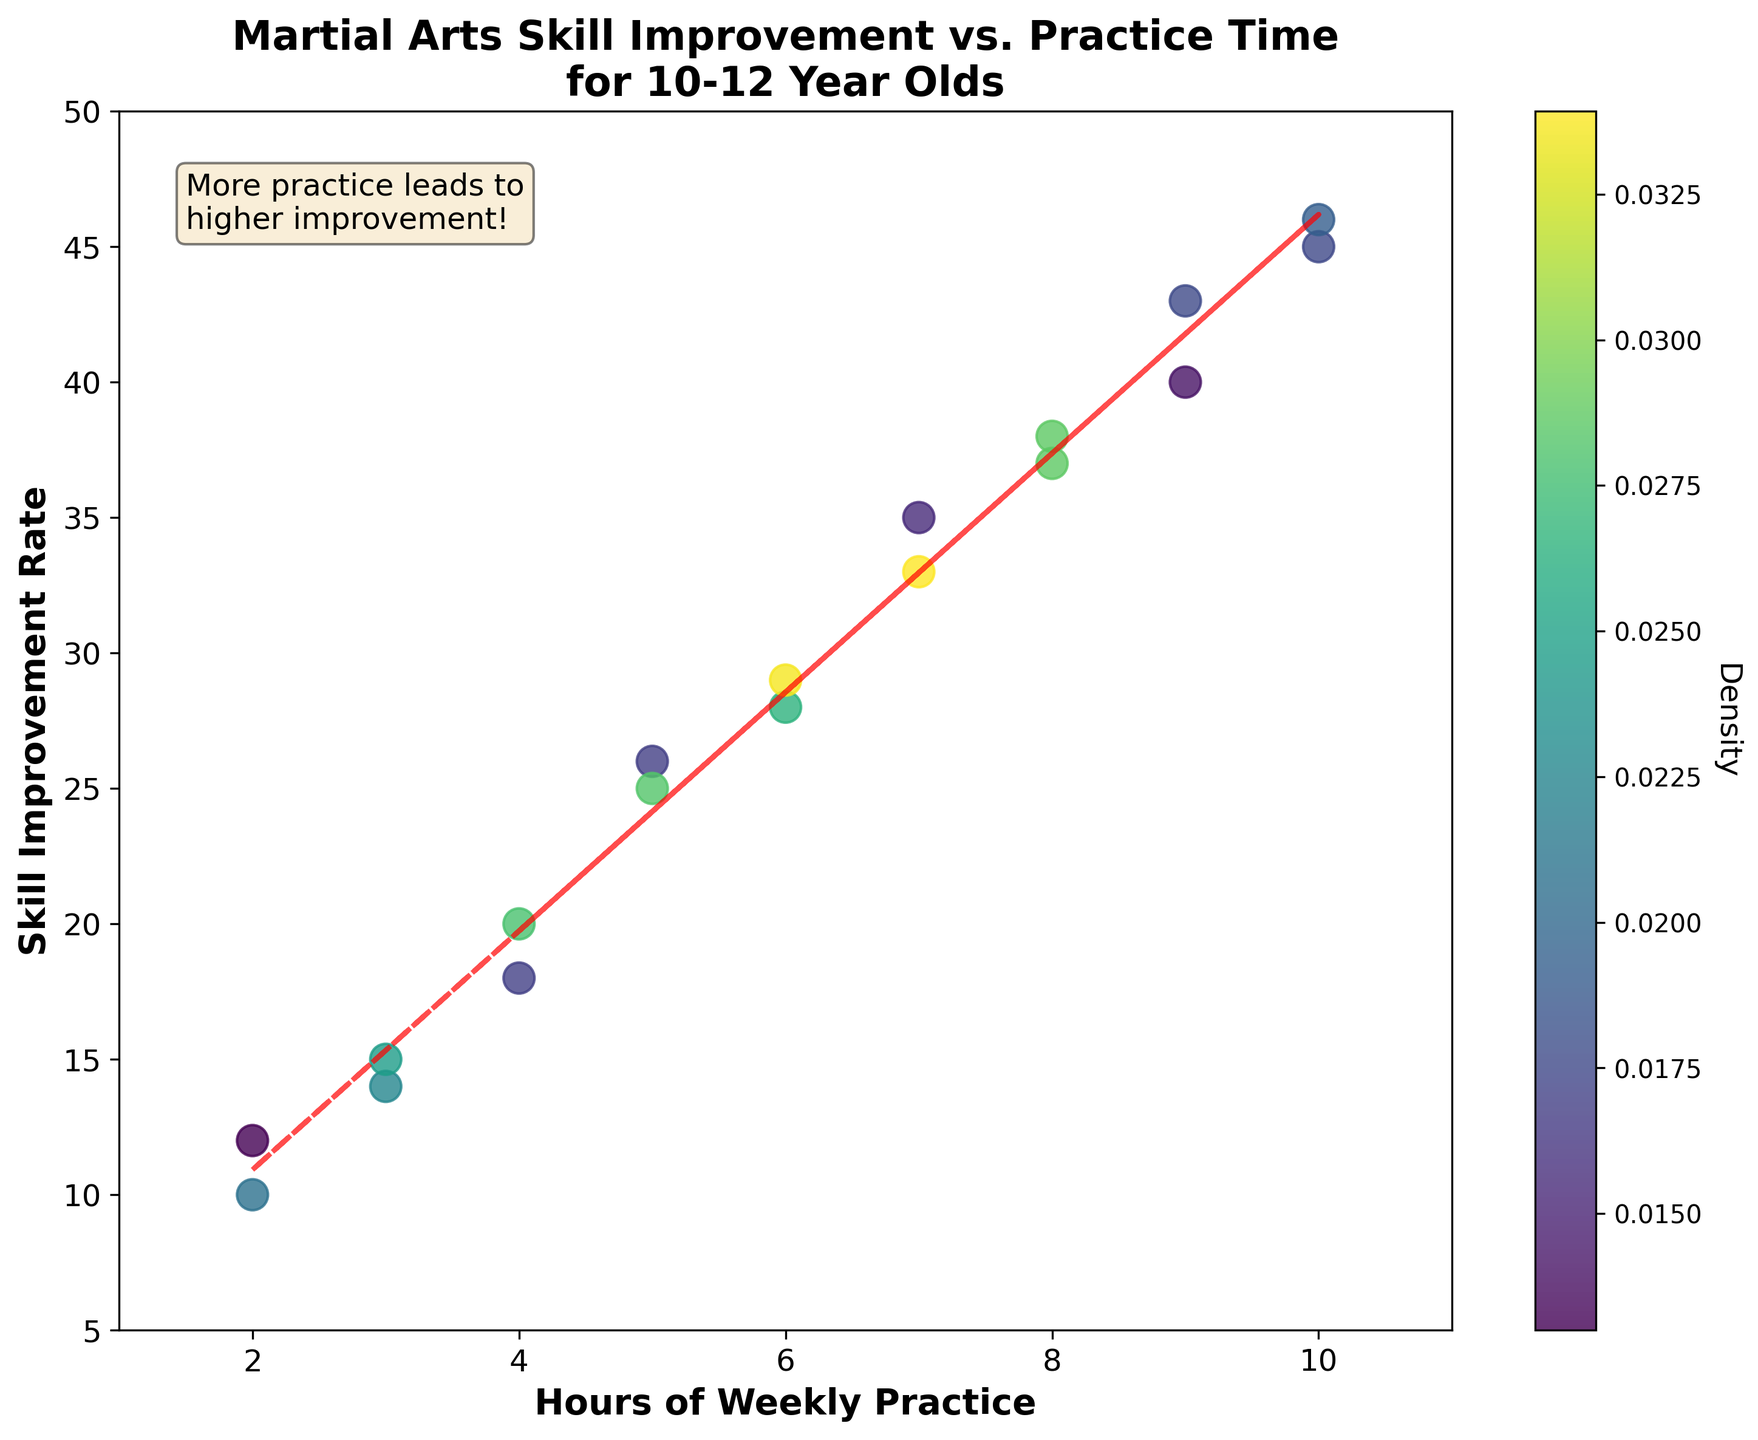What is the title of the plot? The title is located at the top center of the plot and describes what the plot is about.
Answer: Martial Arts Skill Improvement vs. Practice Time for 10-12 Year Olds What are the labels for the x-axis and y-axis? The x-axis label is at the bottom along the horizontal axis, and the y-axis label is on the left along the vertical axis.
Answer: 'Hours of Weekly Practice' and 'Skill Improvement Rate' How many hours of weekly practice corresponds to the highest skill improvement rate on the plot? To find this, locate the point farthest to the right and check the x-axis value for that point.
Answer: 10 hours What is the range of the skill improvement rate displayed in the plot? Observe the minimum and maximum values along the y-axis on the plot.
Answer: 5 to 50 Which color represents the highest density of data points? The densest areas are usually represented by the darkest or most intense color on a density plot, as shown in the colorbar.
Answer: Dark green How does the density of data points change as the hours of weekly practice increase? As the x-axis values increase, follow the scatter points and observe their color changes based on the colorbar.
Answer: The density decreases Is there a clear trend between hours of weekly practice and skill improvement rate? Look at the placement and slope of the best fit line as it indicates the general trend between x and y values.
Answer: Yes, more practice hours generally lead to higher skill improvement rates What is the approximate skill improvement rate for 6 hours of weekly practice? Locate the point corresponding to 6 hours on the x-axis and check the y-axis value for that point.
Answer: Approximately 28-29 What does the red dashed line represent in the plot? This line is typically a best fit line indicating the general trend or relationship between the plotted variables.
Answer: Trend line showing positive correlation How does the annotation box explain the relationship between practice and improvement? The text within the box provides a summary or insight based on the visual data, often located within the plot.
Answer: More practice leads to higher improvement! 